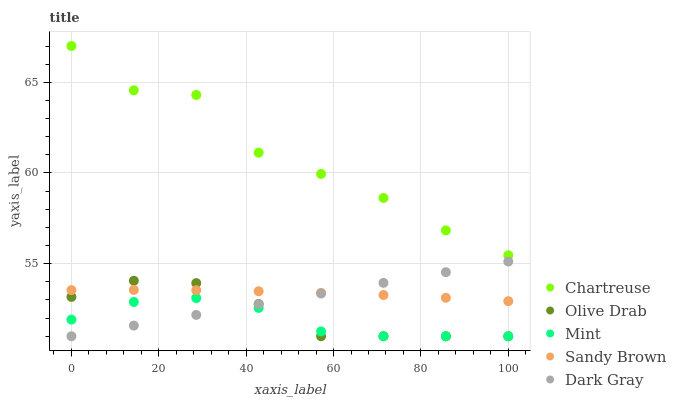Does Mint have the minimum area under the curve?
Answer yes or no. Yes. Does Chartreuse have the maximum area under the curve?
Answer yes or no. Yes. Does Sandy Brown have the minimum area under the curve?
Answer yes or no. No. Does Sandy Brown have the maximum area under the curve?
Answer yes or no. No. Is Dark Gray the smoothest?
Answer yes or no. Yes. Is Chartreuse the roughest?
Answer yes or no. Yes. Is Sandy Brown the smoothest?
Answer yes or no. No. Is Sandy Brown the roughest?
Answer yes or no. No. Does Dark Gray have the lowest value?
Answer yes or no. Yes. Does Sandy Brown have the lowest value?
Answer yes or no. No. Does Chartreuse have the highest value?
Answer yes or no. Yes. Does Sandy Brown have the highest value?
Answer yes or no. No. Is Mint less than Chartreuse?
Answer yes or no. Yes. Is Chartreuse greater than Olive Drab?
Answer yes or no. Yes. Does Mint intersect Dark Gray?
Answer yes or no. Yes. Is Mint less than Dark Gray?
Answer yes or no. No. Is Mint greater than Dark Gray?
Answer yes or no. No. Does Mint intersect Chartreuse?
Answer yes or no. No. 